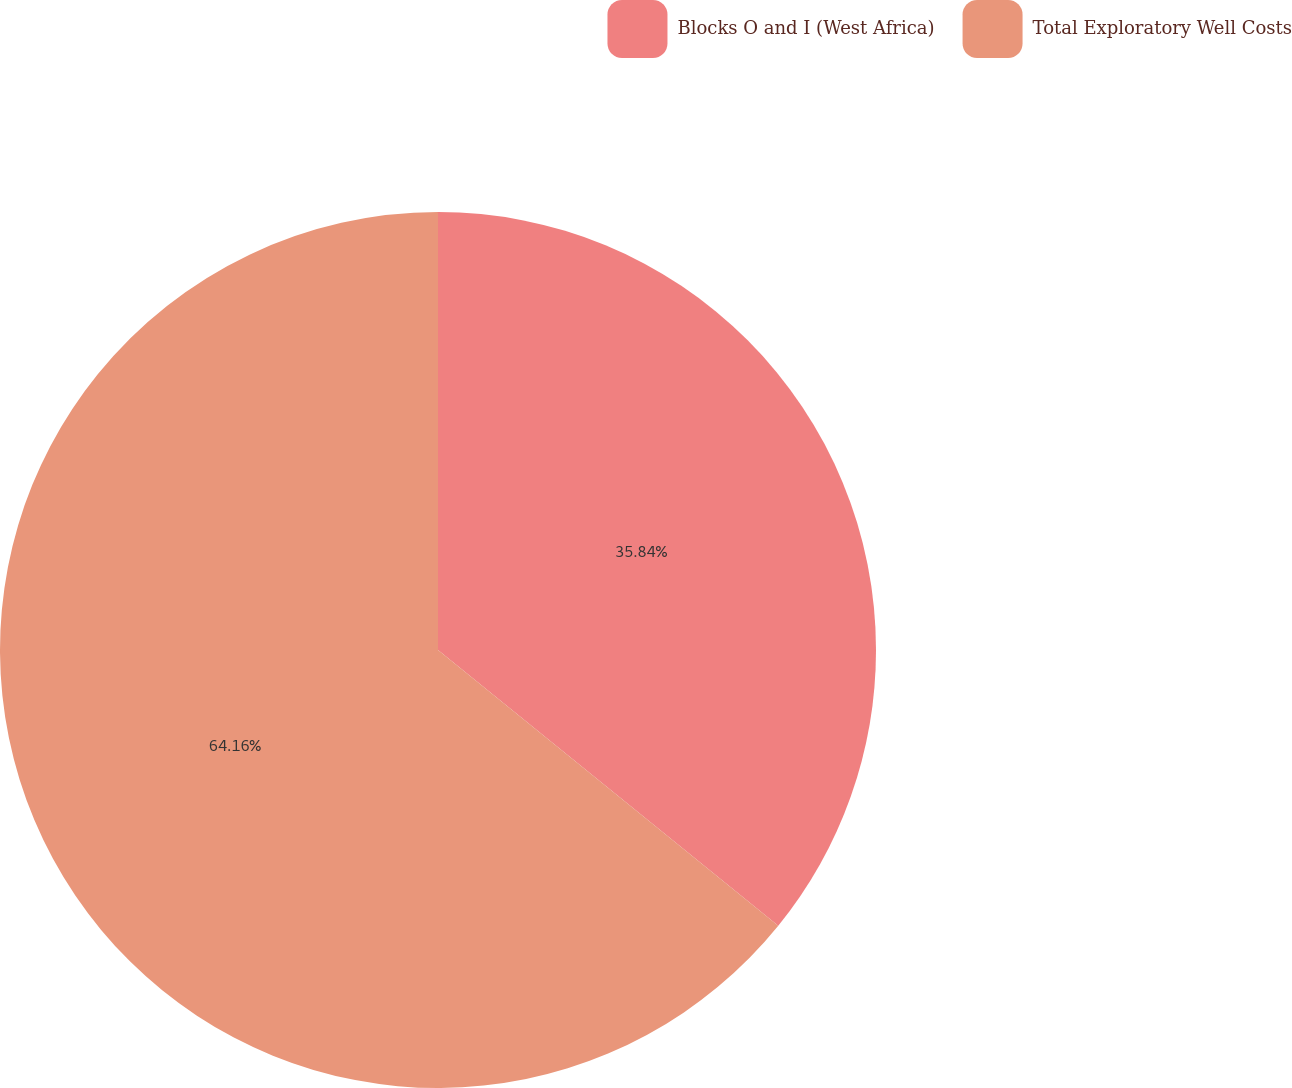<chart> <loc_0><loc_0><loc_500><loc_500><pie_chart><fcel>Blocks O and I (West Africa)<fcel>Total Exploratory Well Costs<nl><fcel>35.84%<fcel>64.16%<nl></chart> 